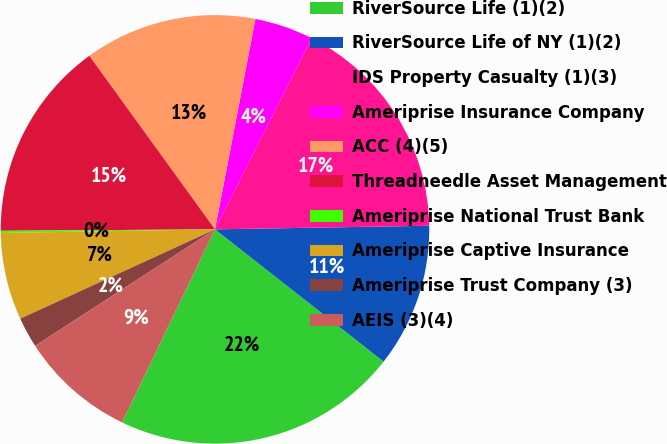<chart> <loc_0><loc_0><loc_500><loc_500><pie_chart><fcel>RiverSource Life (1)(2)<fcel>RiverSource Life of NY (1)(2)<fcel>IDS Property Casualty (1)(3)<fcel>Ameriprise Insurance Company<fcel>ACC (4)(5)<fcel>Threadneedle Asset Management<fcel>Ameriprise National Trust Bank<fcel>Ameriprise Captive Insurance<fcel>Ameriprise Trust Company (3)<fcel>AEIS (3)(4)<nl><fcel>21.56%<fcel>10.86%<fcel>17.28%<fcel>4.44%<fcel>13.0%<fcel>15.14%<fcel>0.16%<fcel>6.58%<fcel>2.3%<fcel>8.72%<nl></chart> 